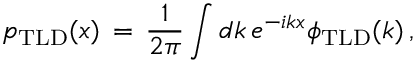Convert formula to latex. <formula><loc_0><loc_0><loc_500><loc_500>p _ { T L D } ( x ) \, = \, \frac { 1 } { 2 \pi } \int d k \, e ^ { - i k x } \phi _ { T L D } ( k ) \, ,</formula> 